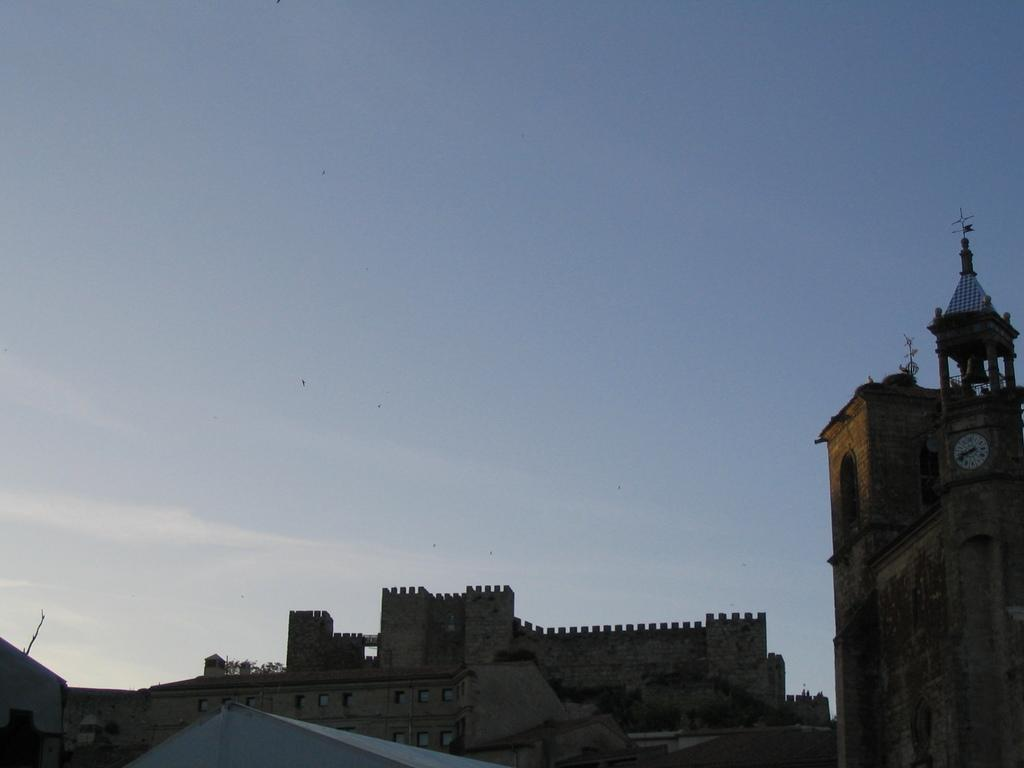What type of structures are present in the image? There are castles in the image. What can be seen in the background of the image? The sky is visible in the background of the image. What is the color of the shed or building at the bottom of the image? The shed or building at the bottom of the image is in white color. Are there any wilderness areas visible in the image? There is no wilderness area present in the image; it features castles, sky, and a white building. Can you see a tray being used in the image? There is no tray visible in the image. 